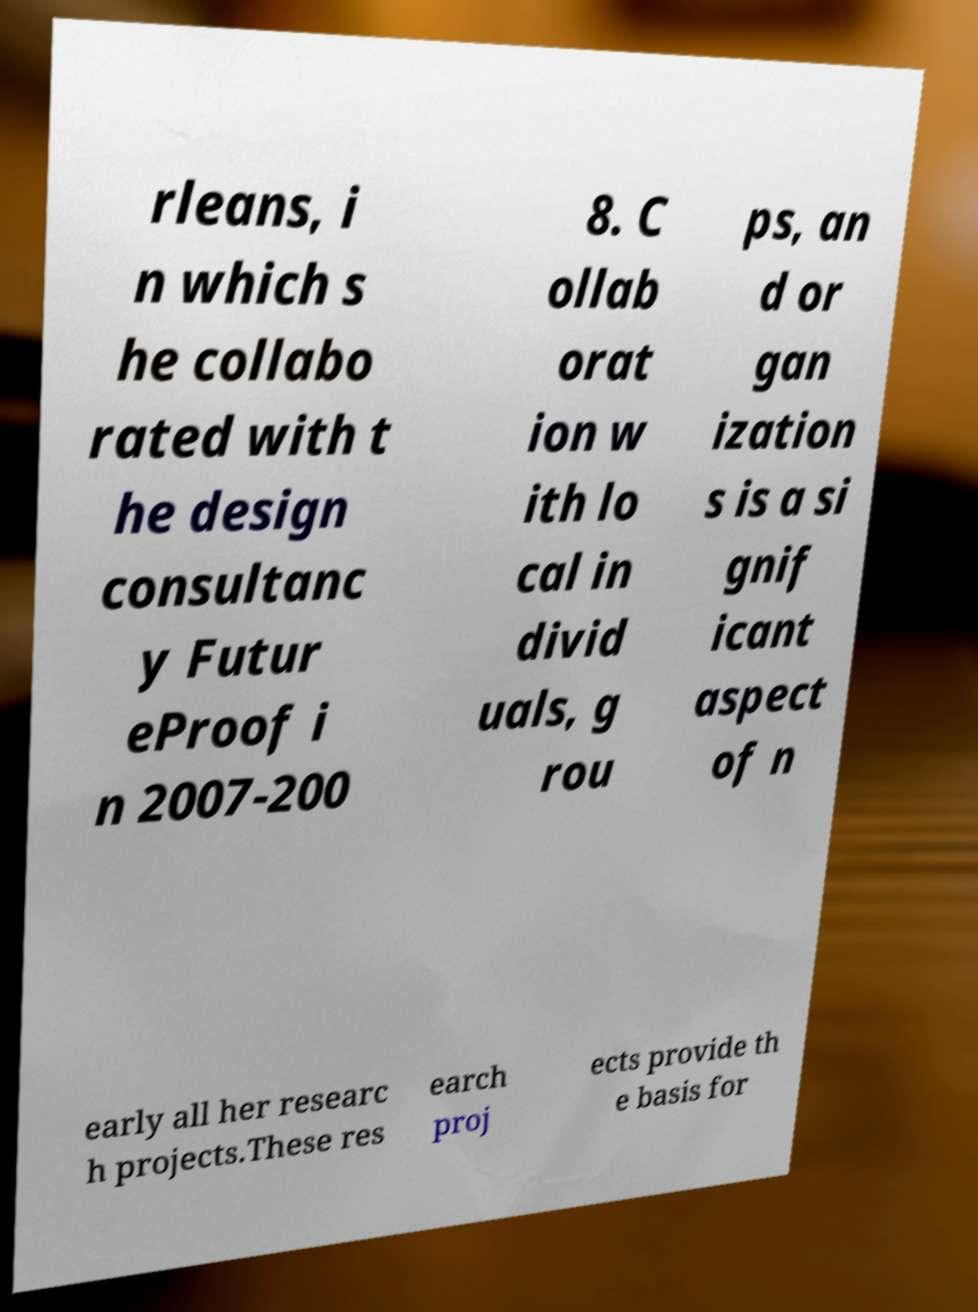There's text embedded in this image that I need extracted. Can you transcribe it verbatim? rleans, i n which s he collabo rated with t he design consultanc y Futur eProof i n 2007-200 8. C ollab orat ion w ith lo cal in divid uals, g rou ps, an d or gan ization s is a si gnif icant aspect of n early all her researc h projects.These res earch proj ects provide th e basis for 